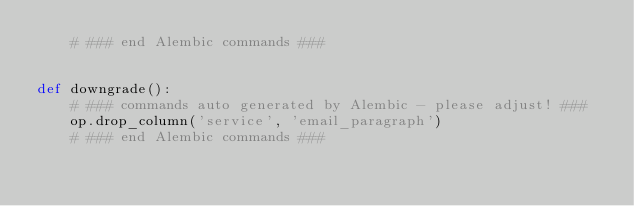<code> <loc_0><loc_0><loc_500><loc_500><_Python_>    # ### end Alembic commands ###


def downgrade():
    # ### commands auto generated by Alembic - please adjust! ###
    op.drop_column('service', 'email_paragraph')
    # ### end Alembic commands ###
</code> 